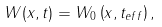Convert formula to latex. <formula><loc_0><loc_0><loc_500><loc_500>W ( x , t ) = W _ { 0 } \left ( x , t _ { e f f } \right ) ,</formula> 